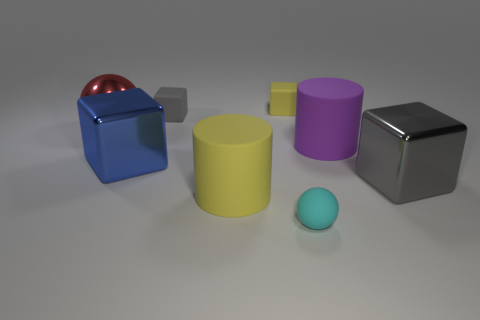Subtract all blue blocks. How many blocks are left? 3 Subtract all yellow rubber blocks. How many blocks are left? 3 Subtract all green blocks. Subtract all green cylinders. How many blocks are left? 4 Add 1 gray shiny objects. How many objects exist? 9 Subtract all cylinders. How many objects are left? 6 Subtract 0 brown spheres. How many objects are left? 8 Subtract all small cyan matte balls. Subtract all large red objects. How many objects are left? 6 Add 7 tiny gray things. How many tiny gray things are left? 8 Add 6 spheres. How many spheres exist? 8 